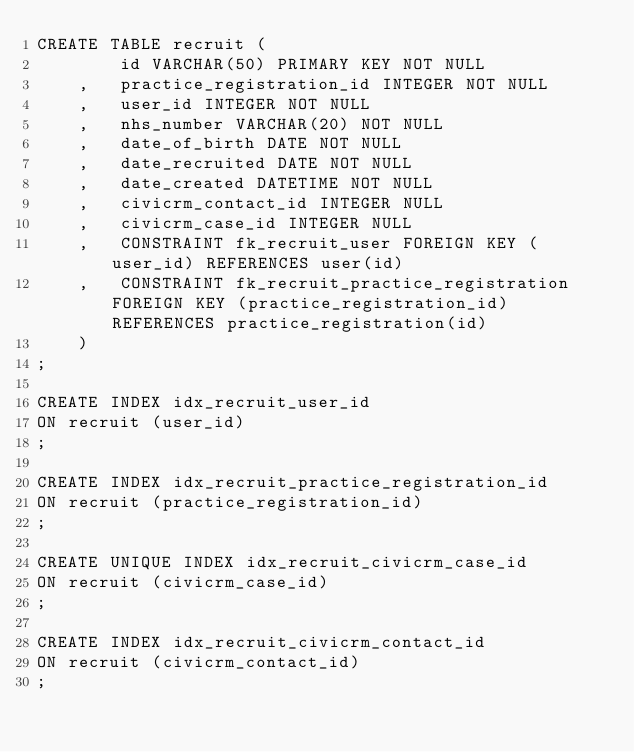Convert code to text. <code><loc_0><loc_0><loc_500><loc_500><_SQL_>CREATE TABLE recruit (
        id VARCHAR(50) PRIMARY KEY NOT NULL
    ,   practice_registration_id INTEGER NOT NULL
    ,   user_id INTEGER NOT NULL
    ,	nhs_number VARCHAR(20) NOT NULL
    ,	date_of_birth DATE NOT NULL
    ,	date_recruited DATE NOT NULL
    ,	date_created DATETIME NOT NULL
    ,   civicrm_contact_id INTEGER NULL
    ,   civicrm_case_id INTEGER NULL
	,	CONSTRAINT fk_recruit_user FOREIGN KEY (user_id) REFERENCES user(id)
	,	CONSTRAINT fk_recruit_practice_registration FOREIGN KEY (practice_registration_id) REFERENCES practice_registration(id)
    )
;

CREATE INDEX idx_recruit_user_id
ON recruit (user_id)
;

CREATE INDEX idx_recruit_practice_registration_id
ON recruit (practice_registration_id)
;

CREATE UNIQUE INDEX idx_recruit_civicrm_case_id
ON recruit (civicrm_case_id)
;

CREATE INDEX idx_recruit_civicrm_contact_id
ON recruit (civicrm_contact_id)
;</code> 